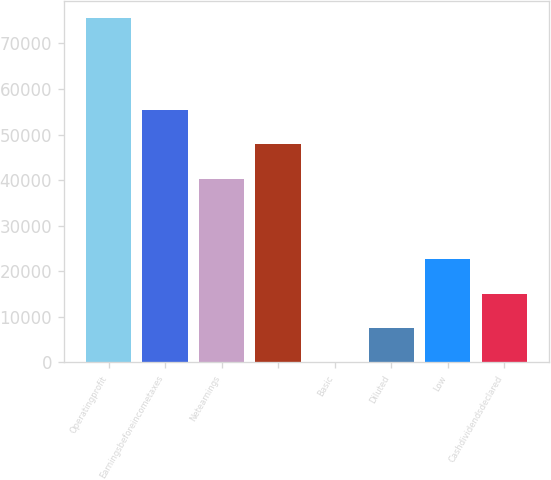Convert chart to OTSL. <chart><loc_0><loc_0><loc_500><loc_500><bar_chart><fcel>Operatingprofit<fcel>Earningsbeforeincometaxes<fcel>Netearnings<fcel>Unnamed: 3<fcel>Basic<fcel>Diluted<fcel>Low<fcel>Cashdividendsdeclared<nl><fcel>75500<fcel>55381.9<fcel>40282<fcel>47832<fcel>0.33<fcel>7550.3<fcel>22650.2<fcel>15100.3<nl></chart> 